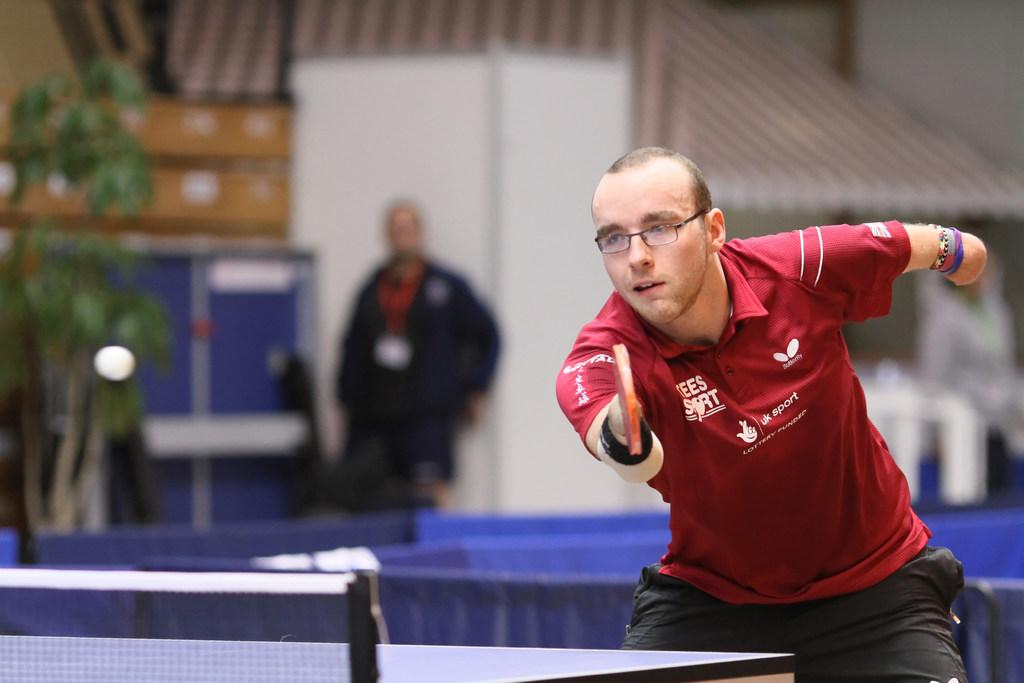What activity is the man in the image engaged in? The man is playing table tennis in the image. What is the main object used for playing table tennis in the image? There is a table tennis board in the image. Can you describe the background of the image? There is a person, a plant, and a name board in the background of the image. What sound can be heard coming from the crack in the table tennis board in the image? There is no crack in the table tennis board in the image, and therefore no sound can be heard from it. 